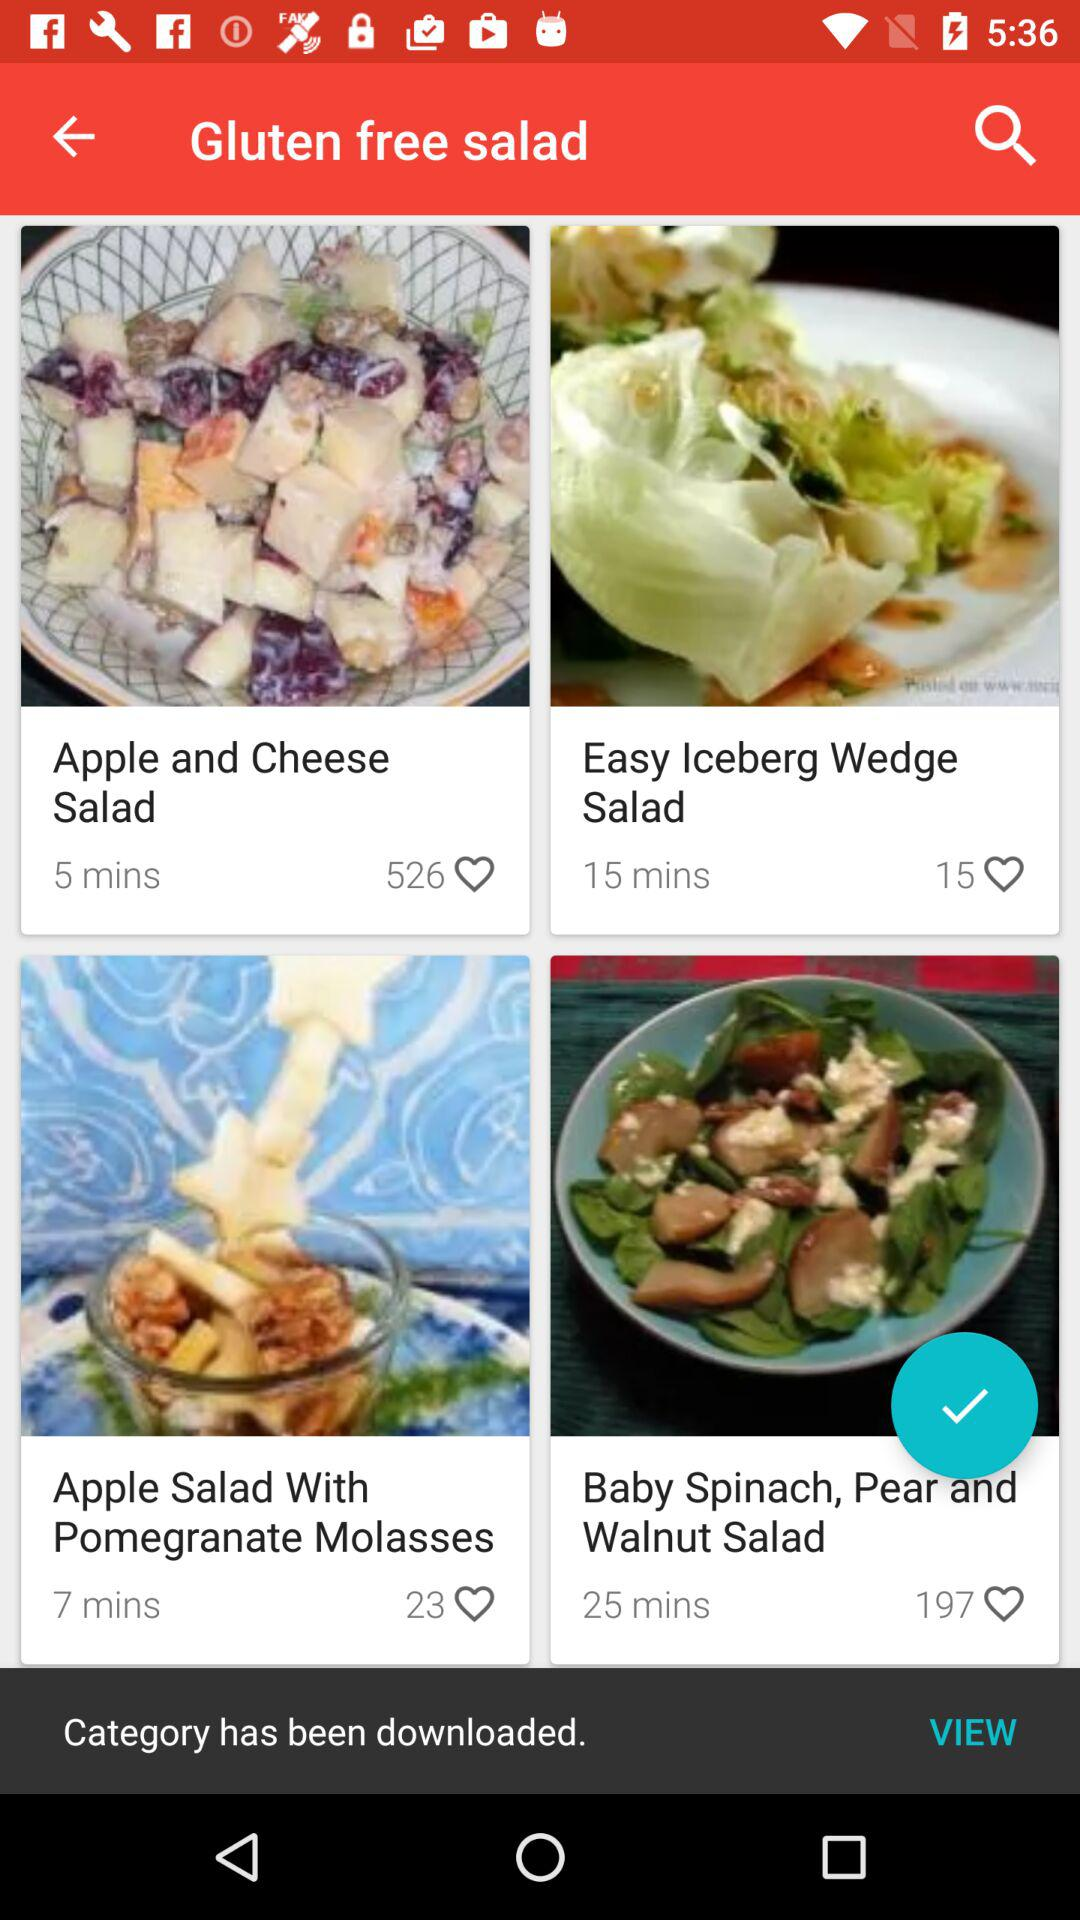What is the time duration mentioned for the "Easy Iceberg Wedge Salad"? The mentioned time duration is 15 minutes. 